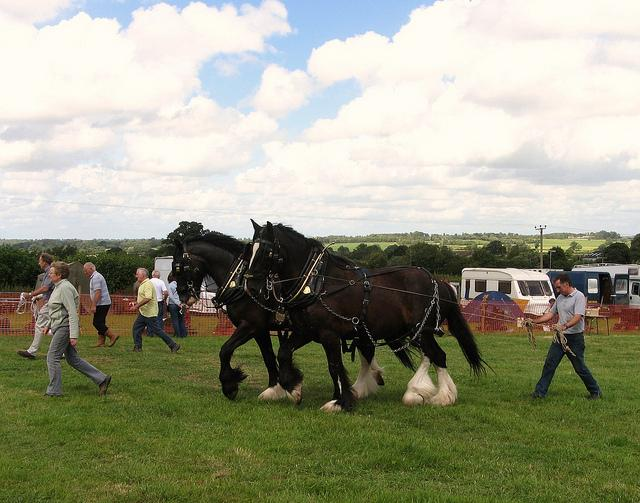Where can the people potentially sleep?

Choices:
A) car
B) trailer
C) field
D) horse trailer 